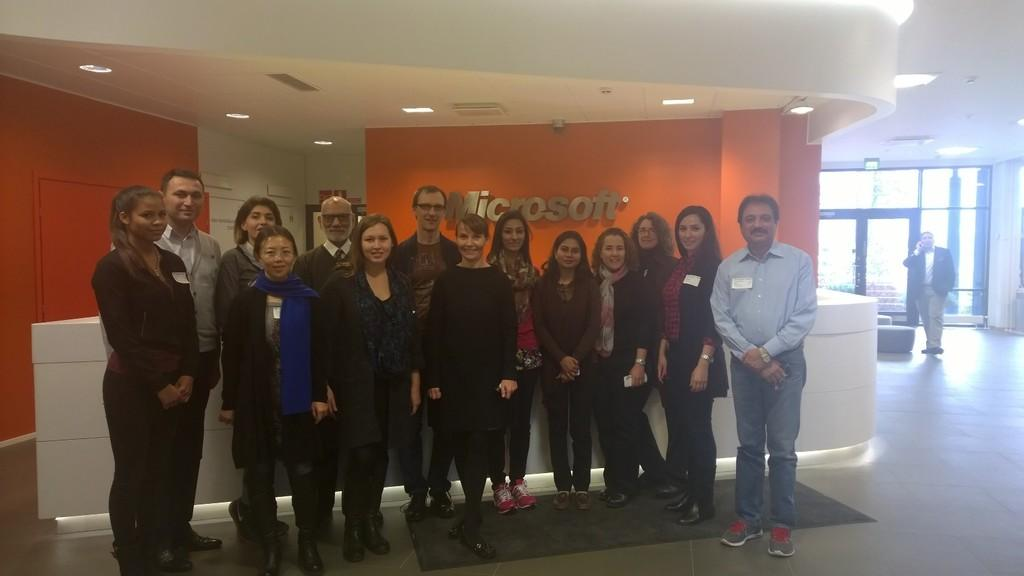What is the main subject of the image? The main subject of the image is a group of people standing. What is the surface that the people are standing on? There is a floor visible in the image. Can you describe the background of the image? There is a person, a wall, and lights in the background of the image. What type of distribution system is visible in the image? There is no distribution system present in the image. What fact can be determined about the people in the image? The facts provided do not allow us to determine any specific fact about the people in the image. 